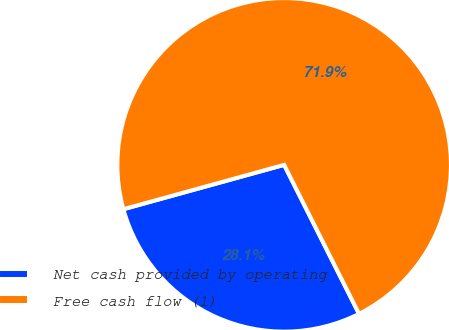<chart> <loc_0><loc_0><loc_500><loc_500><pie_chart><fcel>Net cash provided by operating<fcel>Free cash flow (1)<nl><fcel>28.13%<fcel>71.87%<nl></chart> 